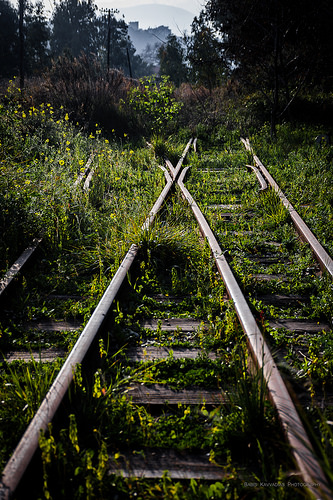<image>
Can you confirm if the tree is above the tracks? No. The tree is not positioned above the tracks. The vertical arrangement shows a different relationship. 